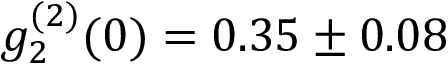<formula> <loc_0><loc_0><loc_500><loc_500>g _ { 2 } ^ { ( 2 ) } ( 0 ) = 0 . 3 5 \pm 0 . 0 8</formula> 